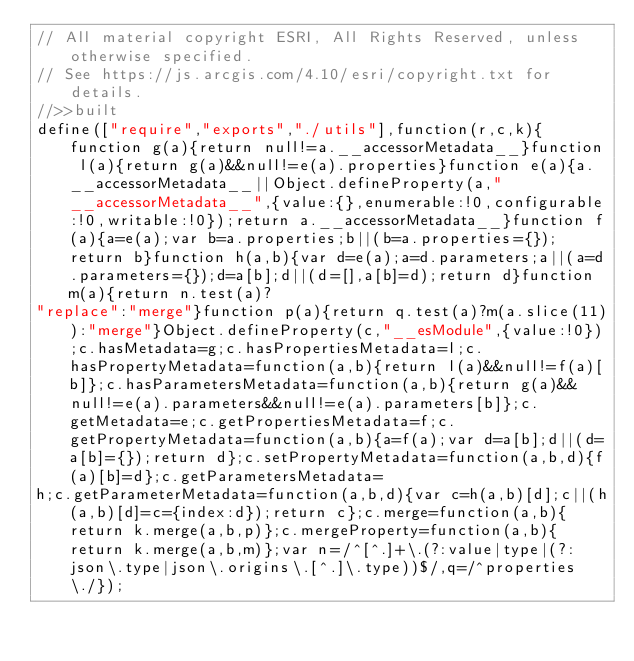Convert code to text. <code><loc_0><loc_0><loc_500><loc_500><_JavaScript_>// All material copyright ESRI, All Rights Reserved, unless otherwise specified.
// See https://js.arcgis.com/4.10/esri/copyright.txt for details.
//>>built
define(["require","exports","./utils"],function(r,c,k){function g(a){return null!=a.__accessorMetadata__}function l(a){return g(a)&&null!=e(a).properties}function e(a){a.__accessorMetadata__||Object.defineProperty(a,"__accessorMetadata__",{value:{},enumerable:!0,configurable:!0,writable:!0});return a.__accessorMetadata__}function f(a){a=e(a);var b=a.properties;b||(b=a.properties={});return b}function h(a,b){var d=e(a);a=d.parameters;a||(a=d.parameters={});d=a[b];d||(d=[],a[b]=d);return d}function m(a){return n.test(a)?
"replace":"merge"}function p(a){return q.test(a)?m(a.slice(11)):"merge"}Object.defineProperty(c,"__esModule",{value:!0});c.hasMetadata=g;c.hasPropertiesMetadata=l;c.hasPropertyMetadata=function(a,b){return l(a)&&null!=f(a)[b]};c.hasParametersMetadata=function(a,b){return g(a)&&null!=e(a).parameters&&null!=e(a).parameters[b]};c.getMetadata=e;c.getPropertiesMetadata=f;c.getPropertyMetadata=function(a,b){a=f(a);var d=a[b];d||(d=a[b]={});return d};c.setPropertyMetadata=function(a,b,d){f(a)[b]=d};c.getParametersMetadata=
h;c.getParameterMetadata=function(a,b,d){var c=h(a,b)[d];c||(h(a,b)[d]=c={index:d});return c};c.merge=function(a,b){return k.merge(a,b,p)};c.mergeProperty=function(a,b){return k.merge(a,b,m)};var n=/^[^.]+\.(?:value|type|(?:json\.type|json\.origins\.[^.]\.type))$/,q=/^properties\./});</code> 